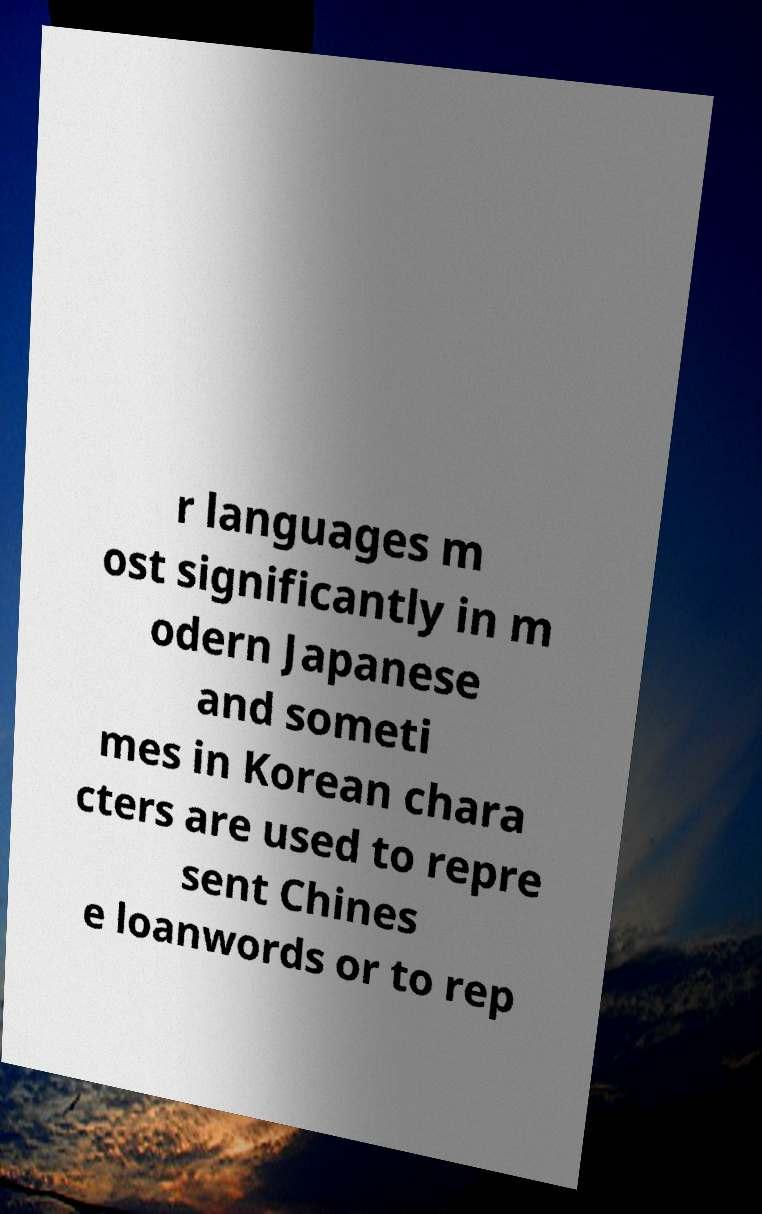Please read and relay the text visible in this image. What does it say? r languages m ost significantly in m odern Japanese and someti mes in Korean chara cters are used to repre sent Chines e loanwords or to rep 